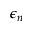Convert formula to latex. <formula><loc_0><loc_0><loc_500><loc_500>\epsilon _ { n }</formula> 